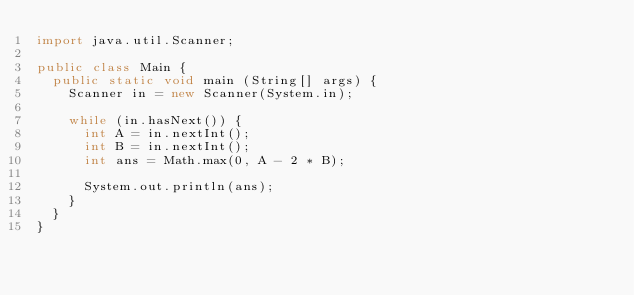<code> <loc_0><loc_0><loc_500><loc_500><_Java_>import java.util.Scanner;

public class Main {
  public static void main (String[] args) {
    Scanner in = new Scanner(System.in);

    while (in.hasNext()) {
      int A = in.nextInt();
      int B = in.nextInt();
      int ans = Math.max(0, A - 2 * B);
      
      System.out.println(ans);
    }
  }
}</code> 